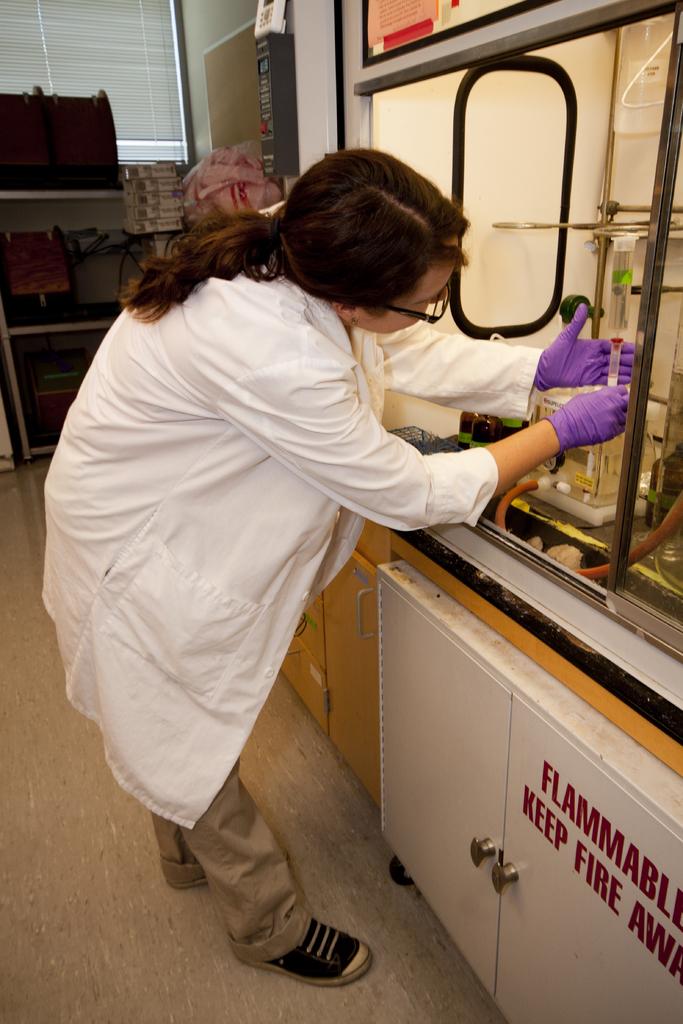What should you do with fire?
Make the answer very short. Keep fire away. 